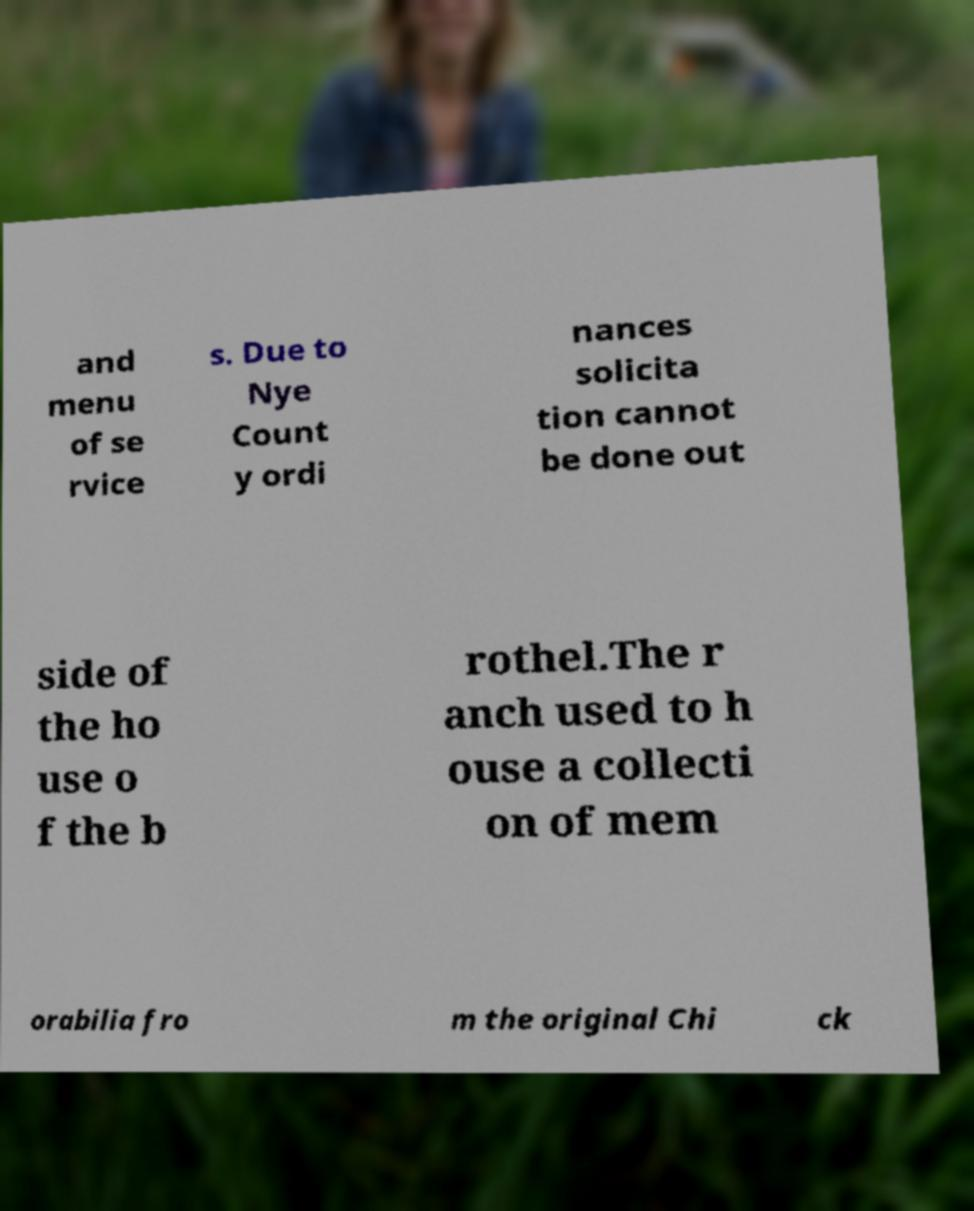For documentation purposes, I need the text within this image transcribed. Could you provide that? and menu of se rvice s. Due to Nye Count y ordi nances solicita tion cannot be done out side of the ho use o f the b rothel.The r anch used to h ouse a collecti on of mem orabilia fro m the original Chi ck 